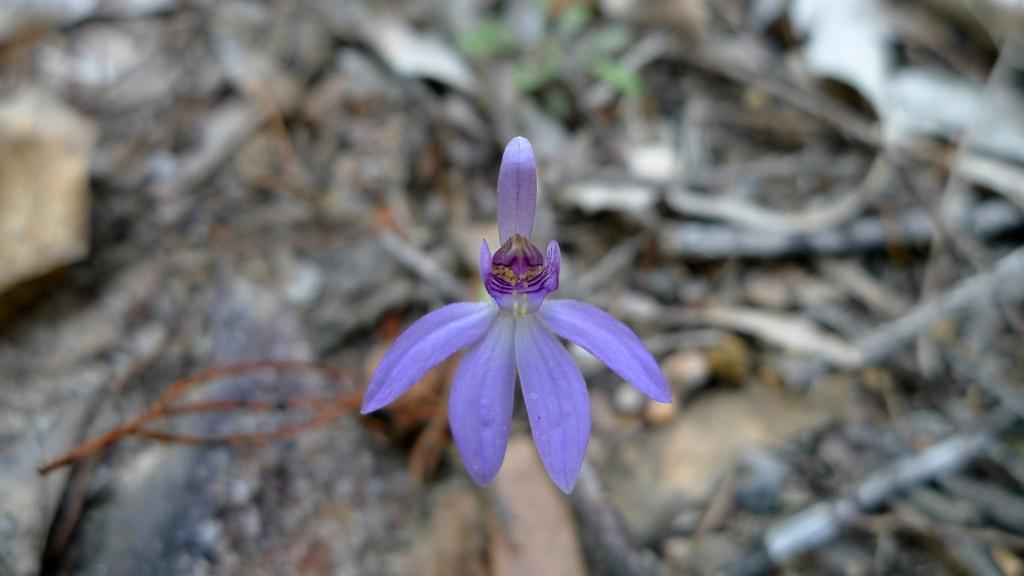Describe this image in one or two sentences. In the middle of this image there is a violet color flower. In the background there are many sticks and stones on the ground. 